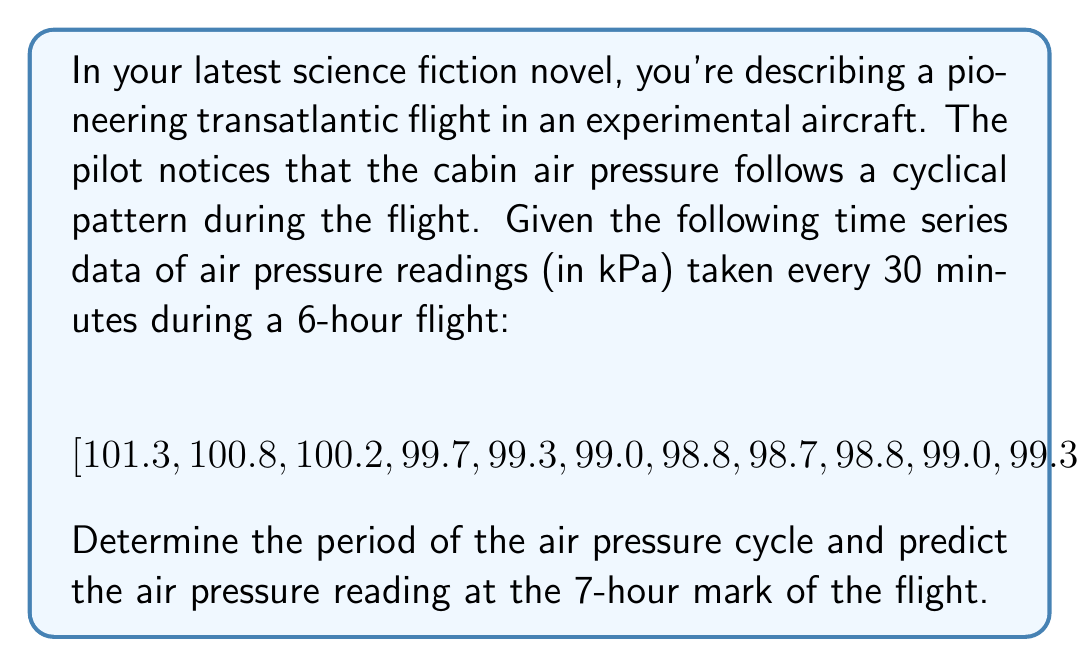Solve this math problem. To solve this problem, we'll follow these steps:

1. Identify the cyclical pattern:
   Looking at the data, we can see that the air pressure decreases, reaches a minimum, and then increases again. This suggests a single complete cycle within the 6-hour flight.

2. Calculate the period of the cycle:
   The period is the time it takes to complete one full cycle. In this case, it's 6 hours or 12 data points (since readings are taken every 30 minutes).

3. Fit a sinusoidal function to the data:
   We can model the air pressure $P(t)$ using the function:
   
   $$ P(t) = A \sin(\omega t + \phi) + C $$
   
   Where:
   $A$ is the amplitude
   $\omega$ is the angular frequency
   $\phi$ is the phase shift
   $C$ is the vertical shift

4. Calculate the angular frequency $\omega$:
   $$ \omega = \frac{2\pi}{T} = \frac{2\pi}{12} = \frac{\pi}{6} $$
   Where $T$ is the period in terms of data points (12).

5. Estimate other parameters:
   $A \approx \frac{101.3 - 98.7}{2} = 1.3$
   $C \approx \frac{101.3 + 98.7}{2} = 100$
   $\phi \approx 0$ (since the cycle starts at its peak)

6. Our final function:
   $$ P(t) = 1.3 \sin(\frac{\pi}{6}t) + 100 $$

7. Predict the air pressure at the 7-hour mark:
   At 7 hours, $t = 14$ (since we have 2 data points per hour)
   
   $$ P(14) = 1.3 \sin(\frac{\pi}{6} \cdot 14) + 100 $$
   $$ = 1.3 \sin(\frac{7\pi}{3}) + 100 $$
   $$ \approx 1.3 \cdot 0.8660 + 100 $$
   $$ \approx 101.13 \text{ kPa} $$
Answer: The period of the air pressure cycle is 6 hours, and the predicted air pressure reading at the 7-hour mark of the flight is approximately 101.13 kPa. 